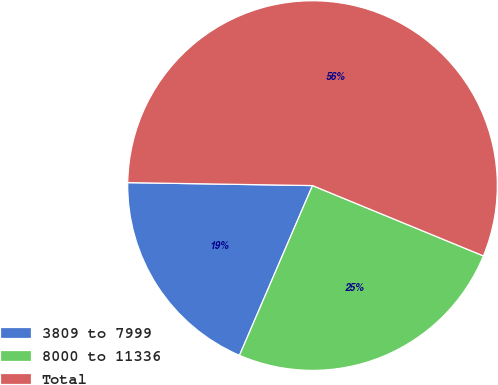<chart> <loc_0><loc_0><loc_500><loc_500><pie_chart><fcel>3809 to 7999<fcel>8000 to 11336<fcel>Total<nl><fcel>18.79%<fcel>25.25%<fcel>55.96%<nl></chart> 